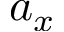<formula> <loc_0><loc_0><loc_500><loc_500>a _ { x }</formula> 